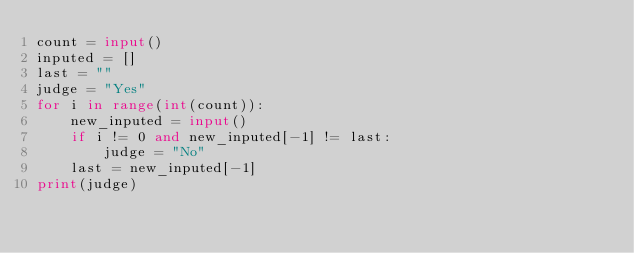Convert code to text. <code><loc_0><loc_0><loc_500><loc_500><_Python_>count = input()
inputed = []
last = ""
judge = "Yes"
for i in range(int(count)):
    new_inputed = input()
    if i != 0 and new_inputed[-1] != last:
        judge = "No"
    last = new_inputed[-1]
print(judge)</code> 